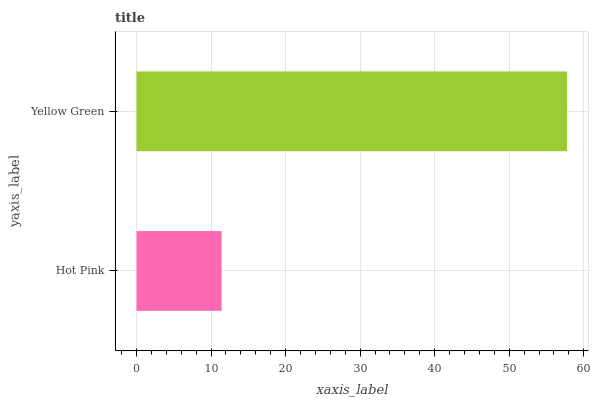Is Hot Pink the minimum?
Answer yes or no. Yes. Is Yellow Green the maximum?
Answer yes or no. Yes. Is Yellow Green the minimum?
Answer yes or no. No. Is Yellow Green greater than Hot Pink?
Answer yes or no. Yes. Is Hot Pink less than Yellow Green?
Answer yes or no. Yes. Is Hot Pink greater than Yellow Green?
Answer yes or no. No. Is Yellow Green less than Hot Pink?
Answer yes or no. No. Is Yellow Green the high median?
Answer yes or no. Yes. Is Hot Pink the low median?
Answer yes or no. Yes. Is Hot Pink the high median?
Answer yes or no. No. Is Yellow Green the low median?
Answer yes or no. No. 